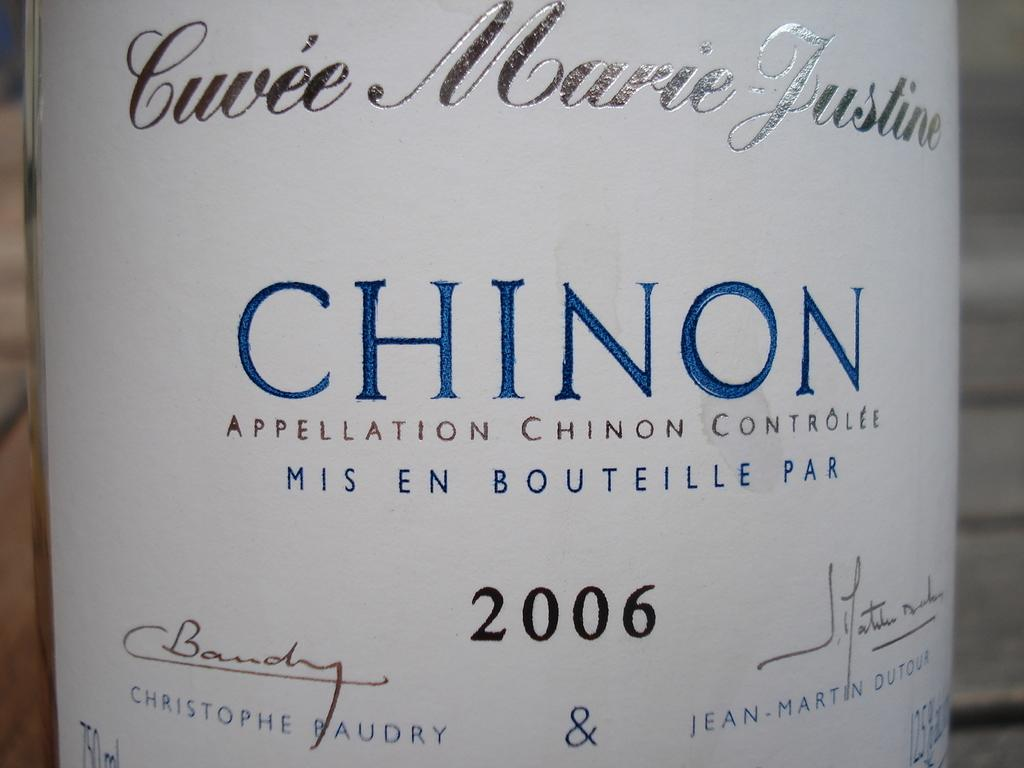<image>
Give a short and clear explanation of the subsequent image. A bottle has the year 2006 and the brand name Chinon. 